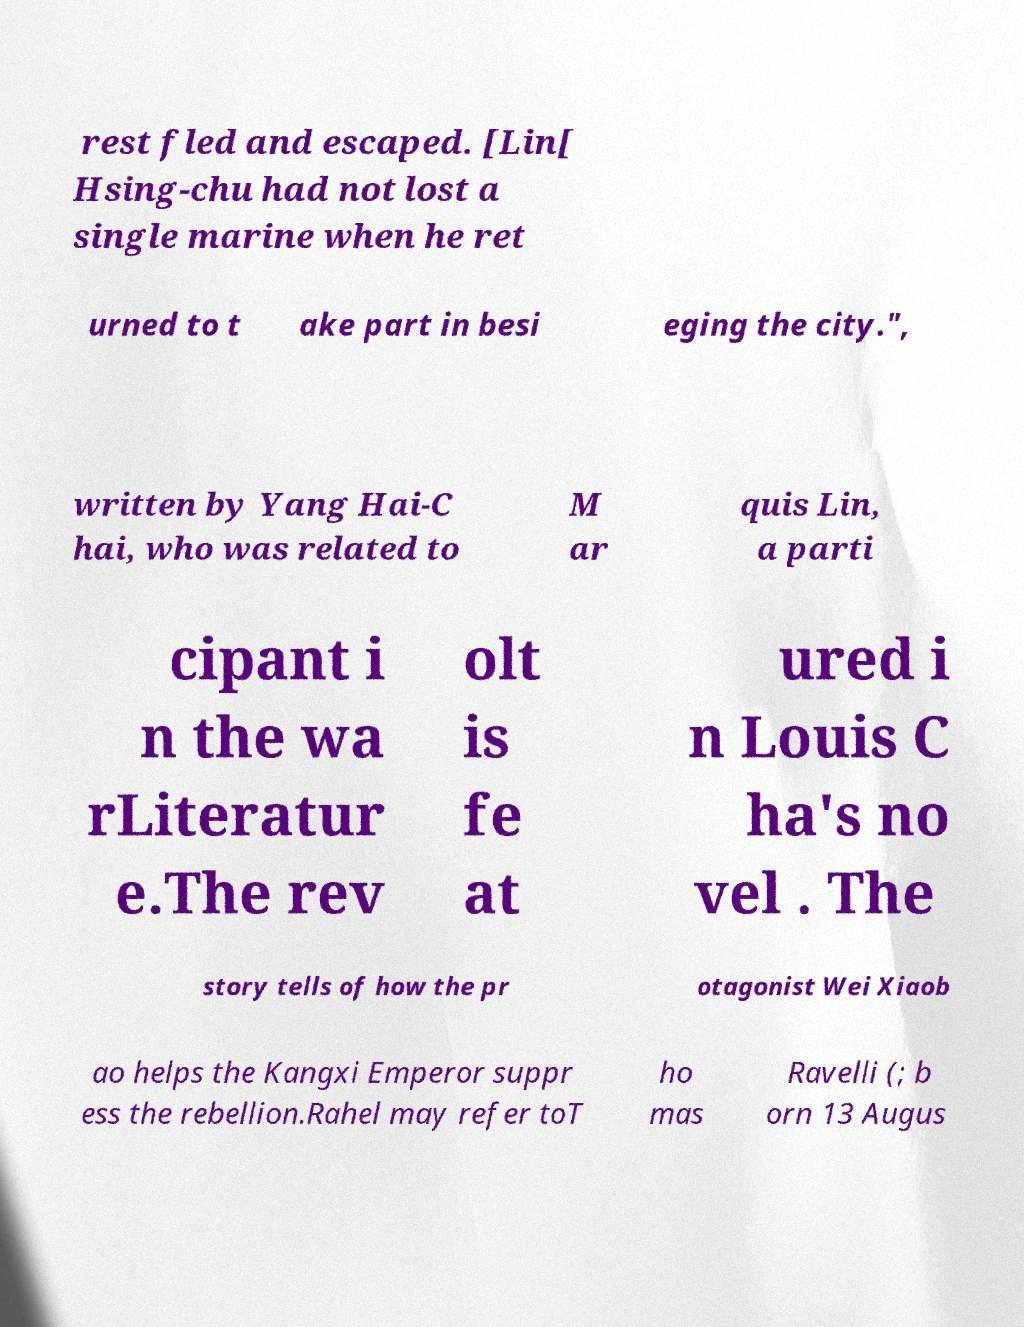Can you accurately transcribe the text from the provided image for me? rest fled and escaped. [Lin[ Hsing-chu had not lost a single marine when he ret urned to t ake part in besi eging the city.", written by Yang Hai-C hai, who was related to M ar quis Lin, a parti cipant i n the wa rLiteratur e.The rev olt is fe at ured i n Louis C ha's no vel . The story tells of how the pr otagonist Wei Xiaob ao helps the Kangxi Emperor suppr ess the rebellion.Rahel may refer toT ho mas Ravelli (; b orn 13 Augus 